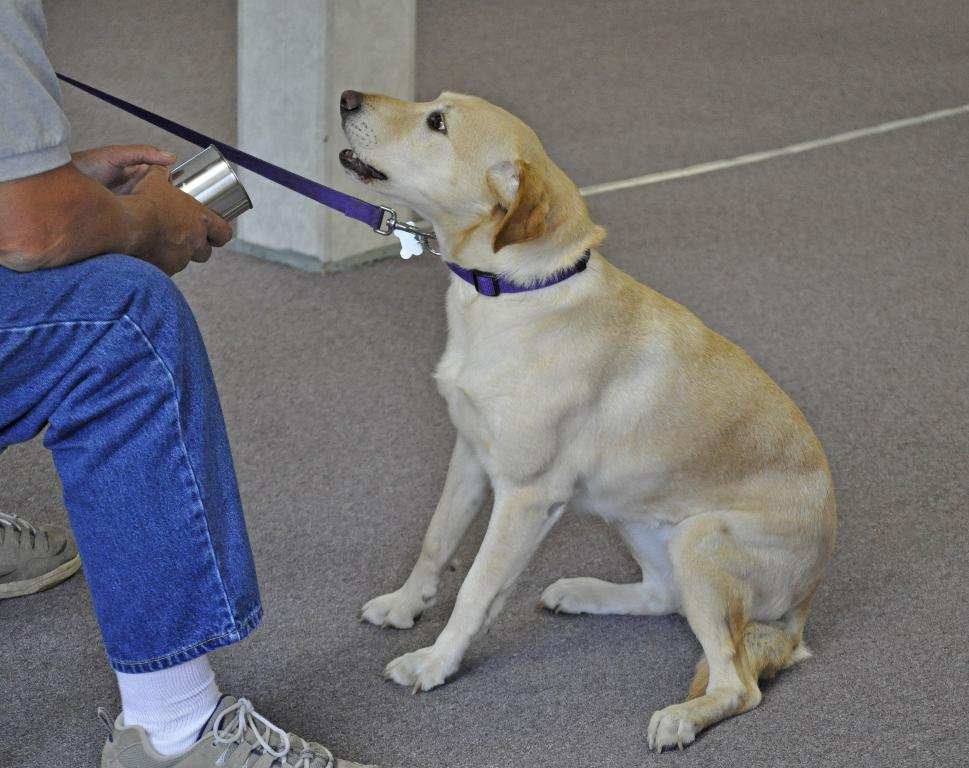What is the person in the image doing? The person is sitting in the image. What is the person holding in the image? The person is holding an object. What architectural feature can be seen in the image? There is a pillar in the image. What animal is present in the image? There is a dog on a surface in the image. What distinguishing feature does the dog have in the image? The dog has a purple color belt around its neck. What type of advertisement is displayed on the pillar in the image? There is no advertisement displayed on the pillar in the image. What type of judge is sitting in the image? There is no judge present in the image; it features a person sitting. 